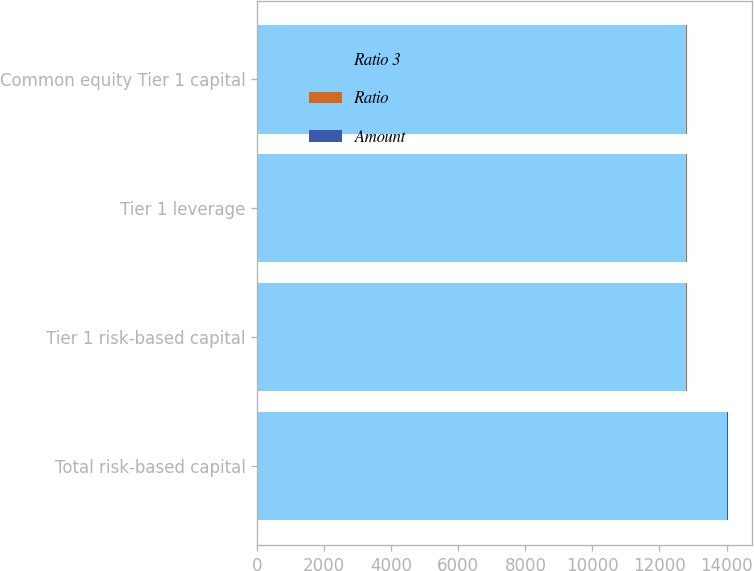Convert chart to OTSL. <chart><loc_0><loc_0><loc_500><loc_500><stacked_bar_chart><ecel><fcel>Total risk-based capital<fcel>Tier 1 risk-based capital<fcel>Tier 1 leverage<fcel>Common equity Tier 1 capital<nl><fcel>Ratio 3<fcel>14013<fcel>12801<fcel>12801<fcel>12801<nl><fcel>Ratio<fcel>15.3<fcel>14<fcel>12.3<fcel>14<nl><fcel>Amount<fcel>17.3<fcel>16<fcel>13.8<fcel>16<nl></chart> 